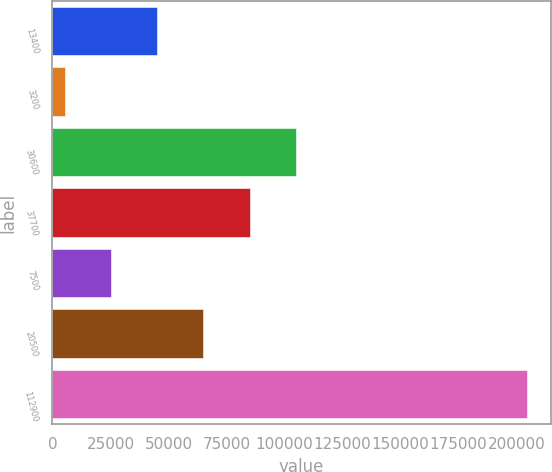<chart> <loc_0><loc_0><loc_500><loc_500><bar_chart><fcel>13400<fcel>3200<fcel>30600<fcel>37700<fcel>7500<fcel>20500<fcel>112900<nl><fcel>45140<fcel>5300<fcel>104900<fcel>84980<fcel>25220<fcel>65060<fcel>204500<nl></chart> 